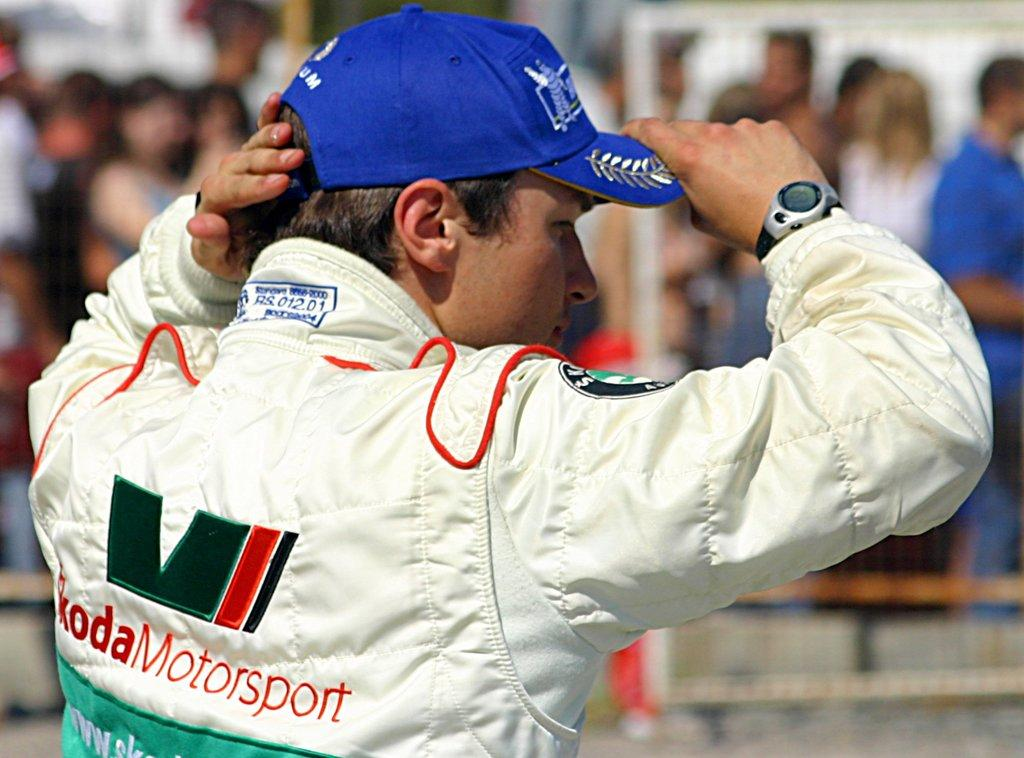Provide a one-sentence caption for the provided image. A driver wearing a jacket that says Koda Motorsport on it. 